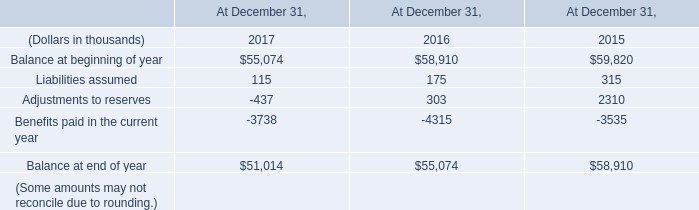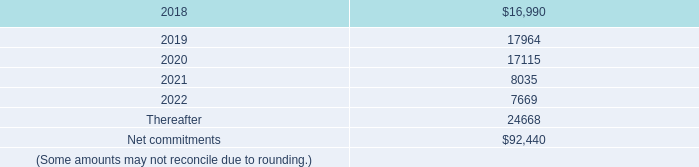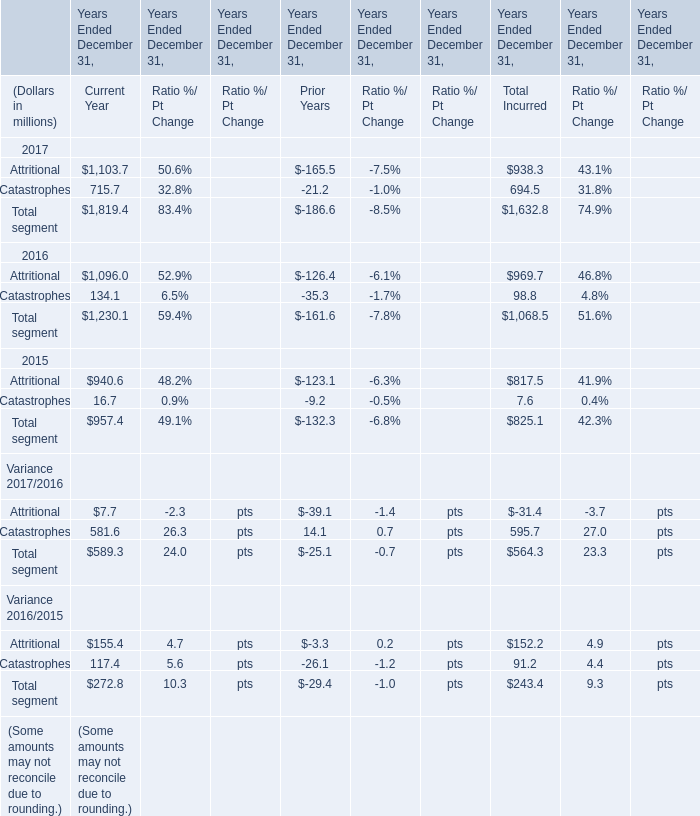What is the sum of Adjustments to reserves of At December 31, 2015, and Attritional of Years Ended December 31, Current Year ? 
Computations: (2310.0 + 1103.7)
Answer: 3413.7. 